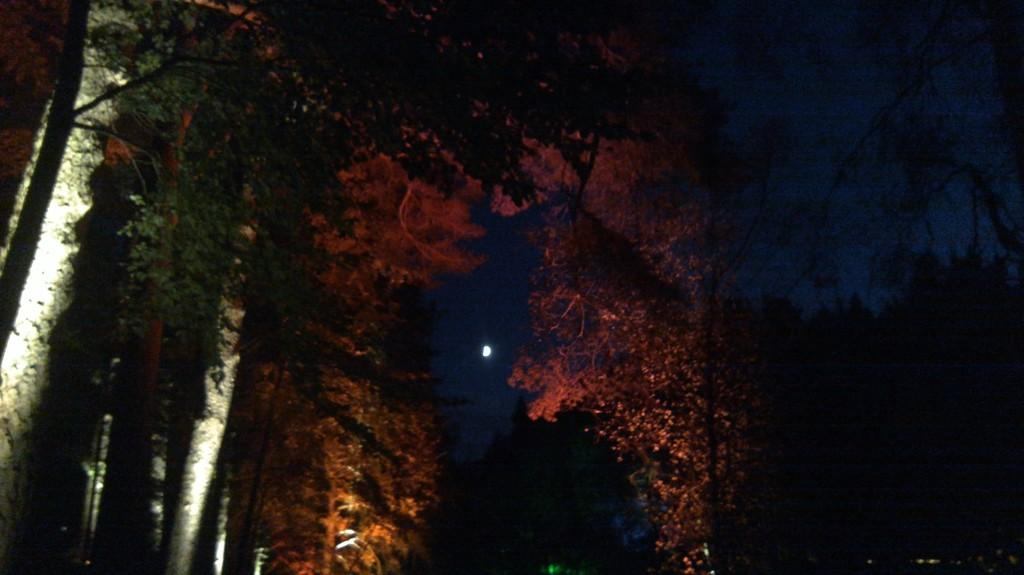What type of natural elements can be seen in the image? There are trees in the image. What celestial body is visible in the sky in the image? The moon is visible in the sky in the image. What type of music is being played by the trees in the image? There is no music being played by the trees in the image, as trees do not have the ability to play music. 